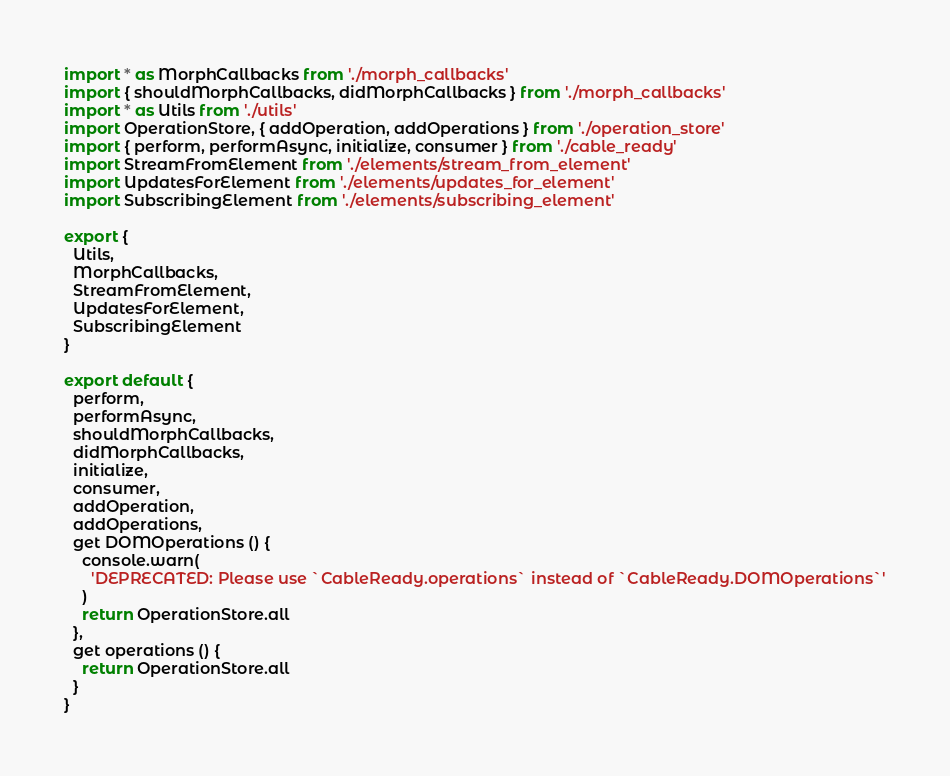<code> <loc_0><loc_0><loc_500><loc_500><_JavaScript_>import * as MorphCallbacks from './morph_callbacks'
import { shouldMorphCallbacks, didMorphCallbacks } from './morph_callbacks'
import * as Utils from './utils'
import OperationStore, { addOperation, addOperations } from './operation_store'
import { perform, performAsync, initialize, consumer } from './cable_ready'
import StreamFromElement from './elements/stream_from_element'
import UpdatesForElement from './elements/updates_for_element'
import SubscribingElement from './elements/subscribing_element'

export {
  Utils,
  MorphCallbacks,
  StreamFromElement,
  UpdatesForElement,
  SubscribingElement
}

export default {
  perform,
  performAsync,
  shouldMorphCallbacks,
  didMorphCallbacks,
  initialize,
  consumer,
  addOperation,
  addOperations,
  get DOMOperations () {
    console.warn(
      'DEPRECATED: Please use `CableReady.operations` instead of `CableReady.DOMOperations`'
    )
    return OperationStore.all
  },
  get operations () {
    return OperationStore.all
  }
}
</code> 